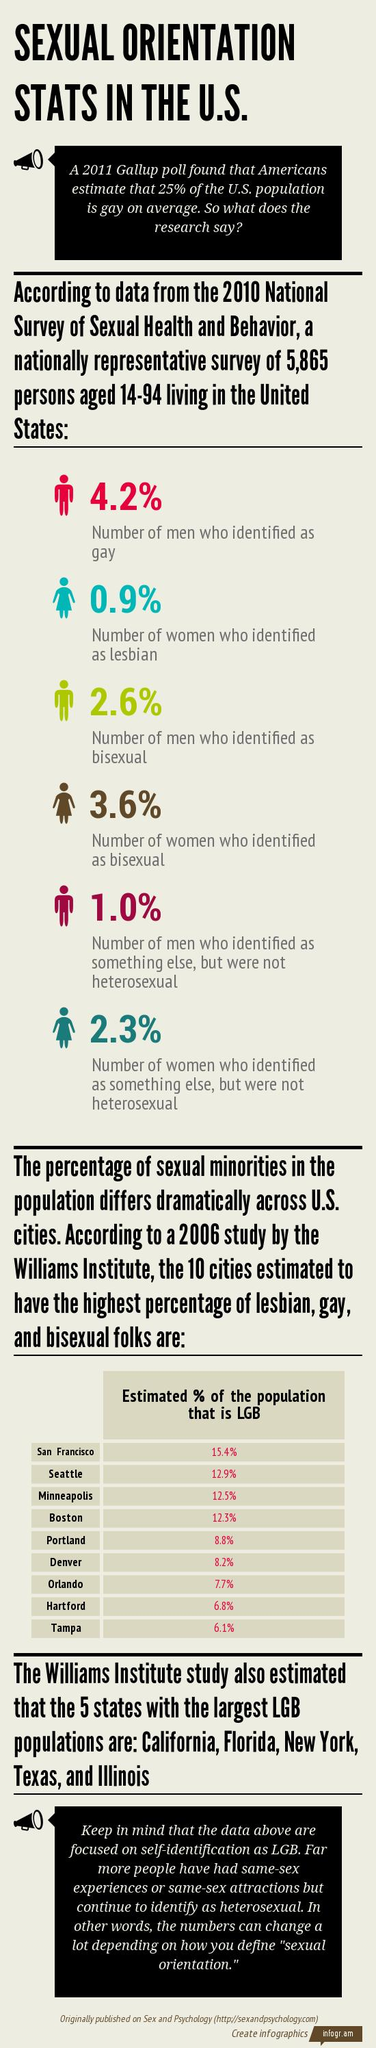Specify some key components in this picture. According to an estimate, approximately 12.3% of the population in Boston identifies as LGB. According to a study conducted by the Williams Institute in the United States, Tampa is estimated to have the lowest percentage of the LGB population among all cities surveyed. According to a study conducted by the Williams Institute in the United States, it is estimated that the city with the highest percentage of LGB population is San Francisco, with an estimated 11.7% of the population identifying as LGB. 